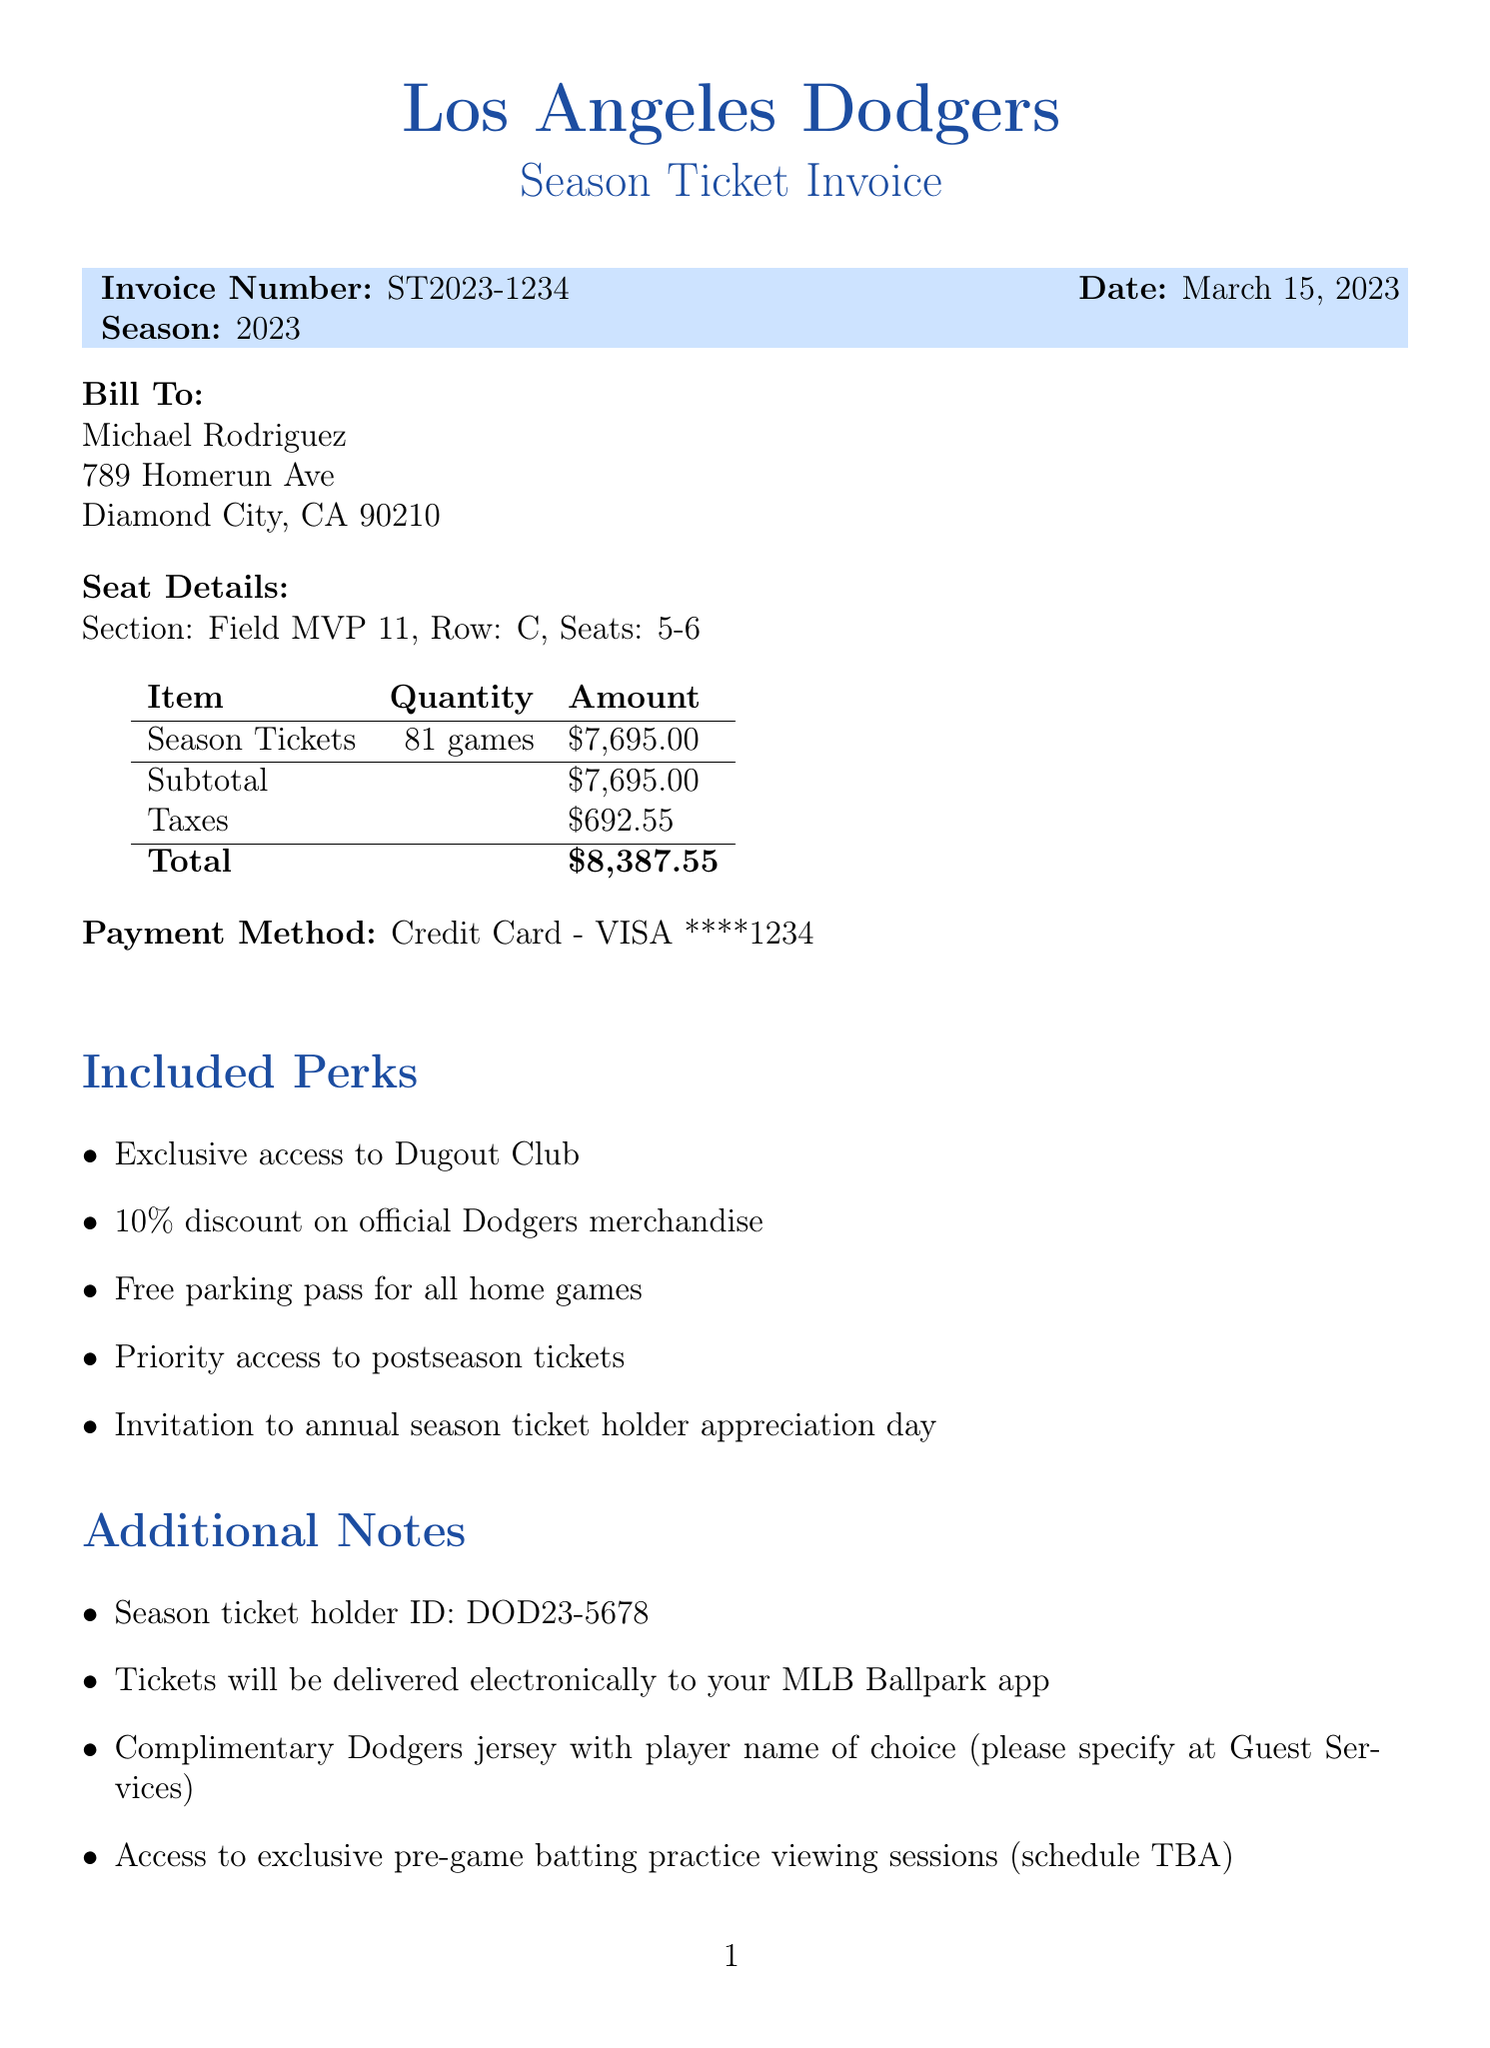What is the invoice number? The invoice number is explicitly stated in the document for reference.
Answer: ST2023-1234 Who is the customer? The customer’s name is mentioned at the beginning of the invoice.
Answer: Michael Rodriguez What is the total amount for the season tickets? The total amount is calculated by adding the subtotal and taxes as provided in the document.
Answer: $8,387.55 How many games are included in the season ticket package? The total number of games is specified in the invoice.
Answer: 81 What is one of the included perks? Several perks are listed in the document, and one example can be easily identified.
Answer: Exclusive access to Dugout Club What is the seat row for the tickets? The seat row is detailed in the seat information section of the invoice.
Answer: C What is the price per game? The price per game is mentioned separately and is crucial for understanding the ticket price structure.
Answer: $95.00 What type of payment method was used? The payment method is indicated in the invoice for clarity on the transaction details.
Answer: Credit Card - VISA ****1234 What is provided as an additional note on jersey selection? The document mentions a specific detail relating to the selection of a complimentary jersey.
Answer: Complimentary Dodgers jersey with player name of choice What will happen to the tickets? The document mentions how tickets will be delivered to the customer, which is important for ticket distribution.
Answer: Tickets will be delivered electronically to your MLB Ballpark app 